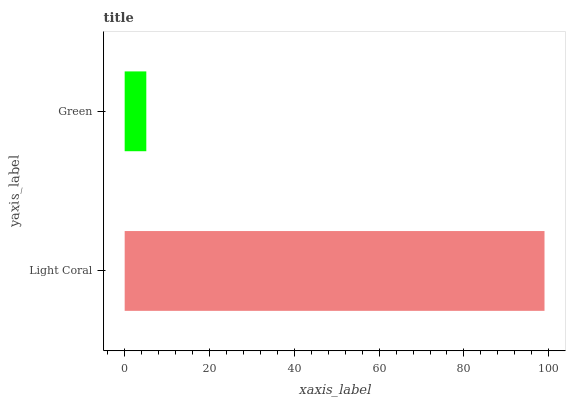Is Green the minimum?
Answer yes or no. Yes. Is Light Coral the maximum?
Answer yes or no. Yes. Is Green the maximum?
Answer yes or no. No. Is Light Coral greater than Green?
Answer yes or no. Yes. Is Green less than Light Coral?
Answer yes or no. Yes. Is Green greater than Light Coral?
Answer yes or no. No. Is Light Coral less than Green?
Answer yes or no. No. Is Light Coral the high median?
Answer yes or no. Yes. Is Green the low median?
Answer yes or no. Yes. Is Green the high median?
Answer yes or no. No. Is Light Coral the low median?
Answer yes or no. No. 